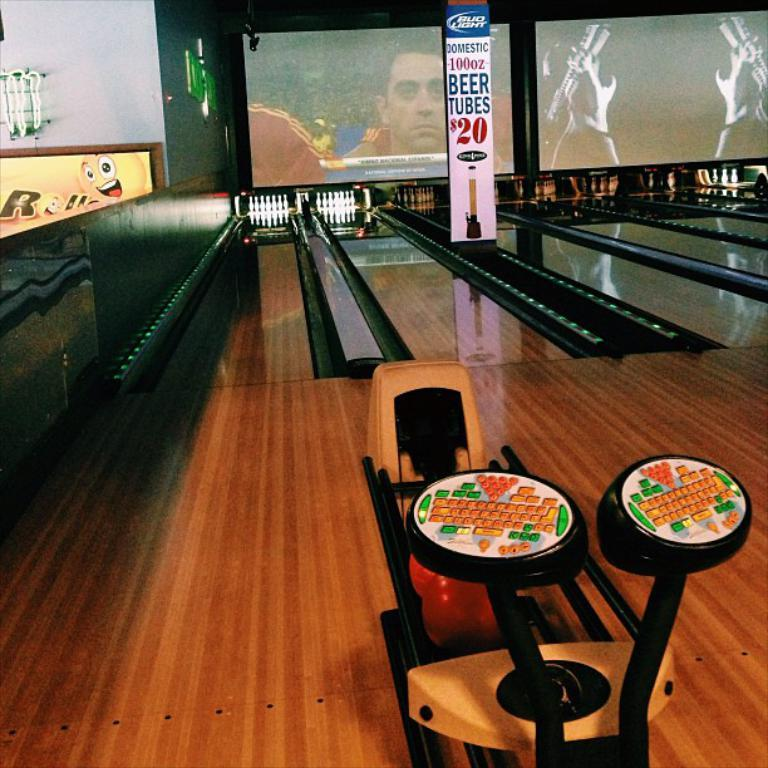What activity is taking place in the image? There is a bowling game in the image. What type of decorations are present in the image? There are posters in the image. What might be used for displaying information or visuals in the image? There are screens in the image. What type of structure can be seen in the image? There are walls in the image. What other objects can be seen in the image besides the bowling game and screens? There are various objects in the image. What type of books are being taxed in the image? There are no books or tax-related information present in the image. 